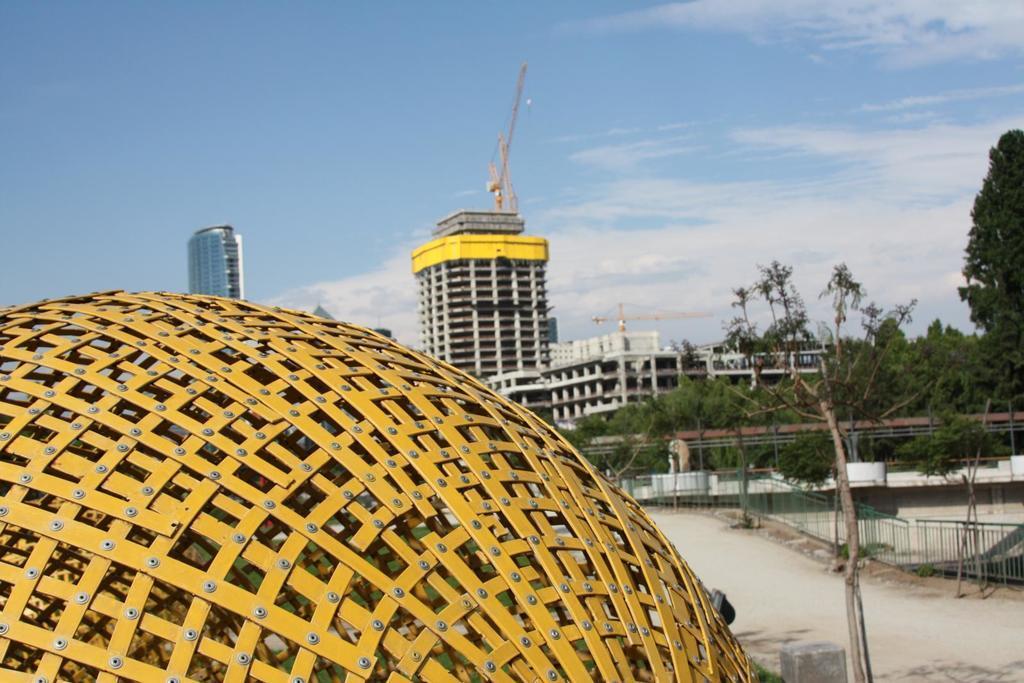Describe this image in one or two sentences. In this image I can see a fence in the middle I can see road and trees and building,at the top I can see the sky. 